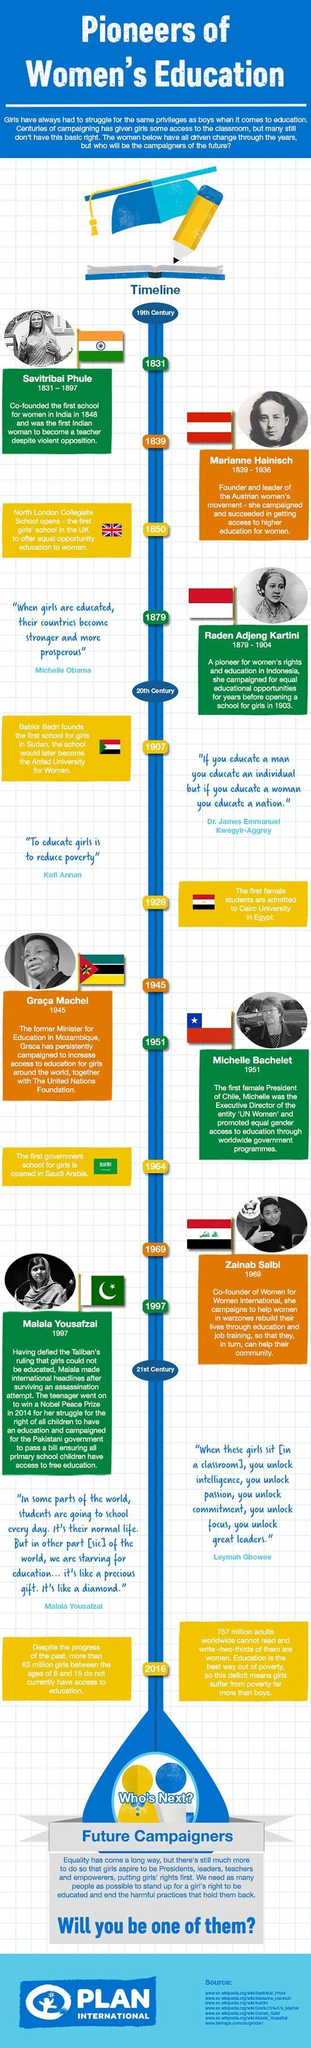How much older was Savitribai Phule than Marianne
Answer the question with a short phrase. 8 What did the first school for girls open in 1964 Saudi Arabia When was the first school in Sudan found 1907 Who says that when girls are educated, countries become stronger and more prosperous Michelle Obama Who is the co-founder of Women for Women International Zainab Salbi 